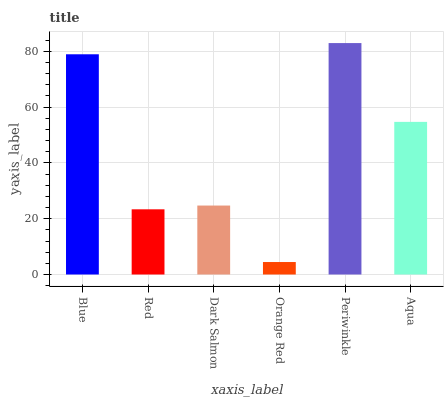Is Orange Red the minimum?
Answer yes or no. Yes. Is Periwinkle the maximum?
Answer yes or no. Yes. Is Red the minimum?
Answer yes or no. No. Is Red the maximum?
Answer yes or no. No. Is Blue greater than Red?
Answer yes or no. Yes. Is Red less than Blue?
Answer yes or no. Yes. Is Red greater than Blue?
Answer yes or no. No. Is Blue less than Red?
Answer yes or no. No. Is Aqua the high median?
Answer yes or no. Yes. Is Dark Salmon the low median?
Answer yes or no. Yes. Is Orange Red the high median?
Answer yes or no. No. Is Blue the low median?
Answer yes or no. No. 